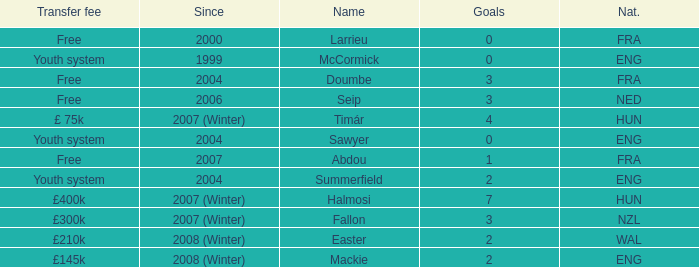What is the nationality of the player with a transfer fee of £400k? HUN. 